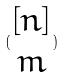Convert formula to latex. <formula><loc_0><loc_0><loc_500><loc_500>( \begin{matrix} [ n ] \\ m \end{matrix} )</formula> 